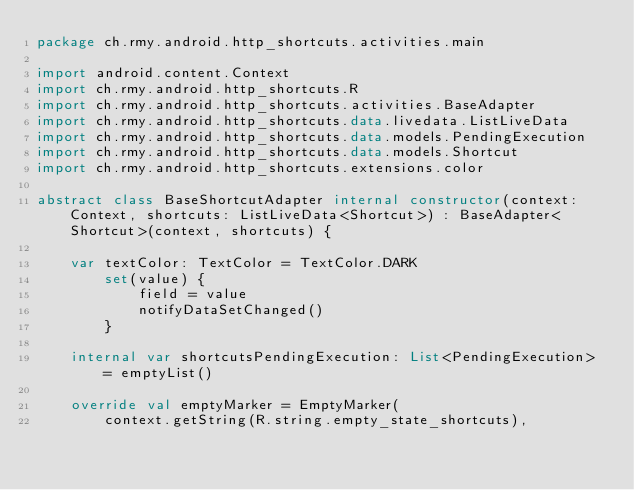<code> <loc_0><loc_0><loc_500><loc_500><_Kotlin_>package ch.rmy.android.http_shortcuts.activities.main

import android.content.Context
import ch.rmy.android.http_shortcuts.R
import ch.rmy.android.http_shortcuts.activities.BaseAdapter
import ch.rmy.android.http_shortcuts.data.livedata.ListLiveData
import ch.rmy.android.http_shortcuts.data.models.PendingExecution
import ch.rmy.android.http_shortcuts.data.models.Shortcut
import ch.rmy.android.http_shortcuts.extensions.color

abstract class BaseShortcutAdapter internal constructor(context: Context, shortcuts: ListLiveData<Shortcut>) : BaseAdapter<Shortcut>(context, shortcuts) {

    var textColor: TextColor = TextColor.DARK
        set(value) {
            field = value
            notifyDataSetChanged()
        }

    internal var shortcutsPendingExecution: List<PendingExecution> = emptyList()

    override val emptyMarker = EmptyMarker(
        context.getString(R.string.empty_state_shortcuts),</code> 